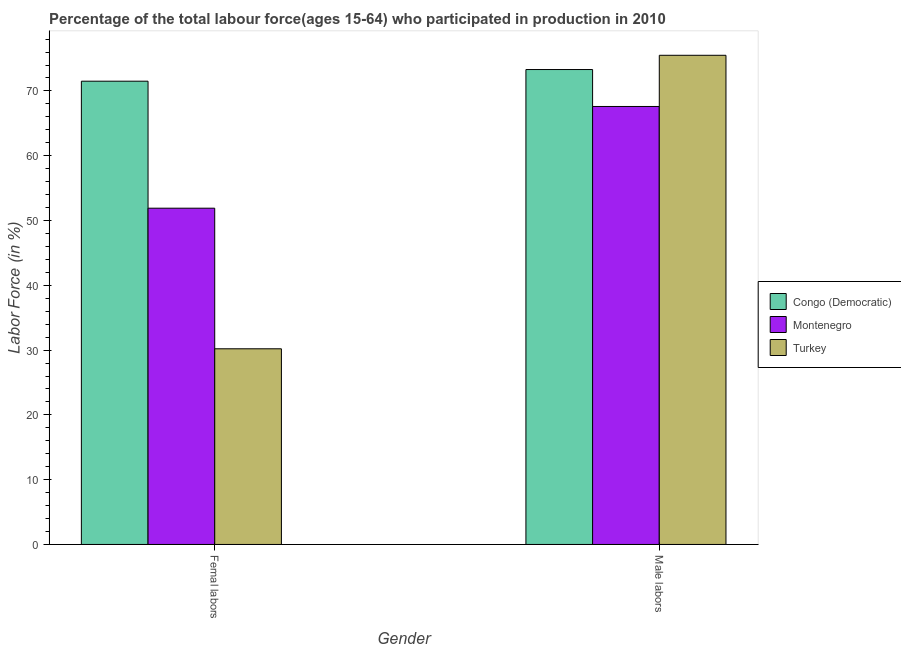How many different coloured bars are there?
Ensure brevity in your answer.  3. Are the number of bars on each tick of the X-axis equal?
Give a very brief answer. Yes. What is the label of the 2nd group of bars from the left?
Offer a very short reply. Male labors. What is the percentage of male labour force in Montenegro?
Keep it short and to the point. 67.6. Across all countries, what is the maximum percentage of female labor force?
Make the answer very short. 71.5. Across all countries, what is the minimum percentage of female labor force?
Your answer should be very brief. 30.2. In which country was the percentage of male labour force maximum?
Provide a succinct answer. Turkey. In which country was the percentage of male labour force minimum?
Provide a short and direct response. Montenegro. What is the total percentage of female labor force in the graph?
Provide a short and direct response. 153.6. What is the difference between the percentage of male labour force in Montenegro and that in Turkey?
Offer a very short reply. -7.9. What is the average percentage of female labor force per country?
Make the answer very short. 51.2. What is the difference between the percentage of female labor force and percentage of male labour force in Congo (Democratic)?
Make the answer very short. -1.8. In how many countries, is the percentage of female labor force greater than 52 %?
Offer a very short reply. 1. What is the ratio of the percentage of female labor force in Montenegro to that in Congo (Democratic)?
Offer a terse response. 0.73. What does the 3rd bar from the left in Femal labors represents?
Your response must be concise. Turkey. What does the 3rd bar from the right in Male labors represents?
Keep it short and to the point. Congo (Democratic). Are all the bars in the graph horizontal?
Provide a succinct answer. No. How are the legend labels stacked?
Offer a very short reply. Vertical. What is the title of the graph?
Your response must be concise. Percentage of the total labour force(ages 15-64) who participated in production in 2010. Does "Netherlands" appear as one of the legend labels in the graph?
Make the answer very short. No. What is the label or title of the X-axis?
Make the answer very short. Gender. What is the Labor Force (in %) of Congo (Democratic) in Femal labors?
Provide a succinct answer. 71.5. What is the Labor Force (in %) of Montenegro in Femal labors?
Your answer should be very brief. 51.9. What is the Labor Force (in %) of Turkey in Femal labors?
Provide a short and direct response. 30.2. What is the Labor Force (in %) of Congo (Democratic) in Male labors?
Offer a very short reply. 73.3. What is the Labor Force (in %) of Montenegro in Male labors?
Your response must be concise. 67.6. What is the Labor Force (in %) of Turkey in Male labors?
Provide a succinct answer. 75.5. Across all Gender, what is the maximum Labor Force (in %) of Congo (Democratic)?
Your response must be concise. 73.3. Across all Gender, what is the maximum Labor Force (in %) of Montenegro?
Offer a very short reply. 67.6. Across all Gender, what is the maximum Labor Force (in %) in Turkey?
Offer a terse response. 75.5. Across all Gender, what is the minimum Labor Force (in %) of Congo (Democratic)?
Offer a terse response. 71.5. Across all Gender, what is the minimum Labor Force (in %) in Montenegro?
Provide a succinct answer. 51.9. Across all Gender, what is the minimum Labor Force (in %) of Turkey?
Keep it short and to the point. 30.2. What is the total Labor Force (in %) of Congo (Democratic) in the graph?
Make the answer very short. 144.8. What is the total Labor Force (in %) of Montenegro in the graph?
Your response must be concise. 119.5. What is the total Labor Force (in %) of Turkey in the graph?
Ensure brevity in your answer.  105.7. What is the difference between the Labor Force (in %) in Congo (Democratic) in Femal labors and that in Male labors?
Provide a short and direct response. -1.8. What is the difference between the Labor Force (in %) in Montenegro in Femal labors and that in Male labors?
Your answer should be very brief. -15.7. What is the difference between the Labor Force (in %) in Turkey in Femal labors and that in Male labors?
Make the answer very short. -45.3. What is the difference between the Labor Force (in %) in Congo (Democratic) in Femal labors and the Labor Force (in %) in Montenegro in Male labors?
Ensure brevity in your answer.  3.9. What is the difference between the Labor Force (in %) in Montenegro in Femal labors and the Labor Force (in %) in Turkey in Male labors?
Provide a succinct answer. -23.6. What is the average Labor Force (in %) of Congo (Democratic) per Gender?
Offer a very short reply. 72.4. What is the average Labor Force (in %) in Montenegro per Gender?
Ensure brevity in your answer.  59.75. What is the average Labor Force (in %) of Turkey per Gender?
Your answer should be compact. 52.85. What is the difference between the Labor Force (in %) in Congo (Democratic) and Labor Force (in %) in Montenegro in Femal labors?
Your response must be concise. 19.6. What is the difference between the Labor Force (in %) in Congo (Democratic) and Labor Force (in %) in Turkey in Femal labors?
Provide a short and direct response. 41.3. What is the difference between the Labor Force (in %) in Montenegro and Labor Force (in %) in Turkey in Femal labors?
Make the answer very short. 21.7. What is the difference between the Labor Force (in %) of Congo (Democratic) and Labor Force (in %) of Montenegro in Male labors?
Keep it short and to the point. 5.7. What is the difference between the Labor Force (in %) in Congo (Democratic) and Labor Force (in %) in Turkey in Male labors?
Ensure brevity in your answer.  -2.2. What is the difference between the Labor Force (in %) in Montenegro and Labor Force (in %) in Turkey in Male labors?
Offer a terse response. -7.9. What is the ratio of the Labor Force (in %) in Congo (Democratic) in Femal labors to that in Male labors?
Your response must be concise. 0.98. What is the ratio of the Labor Force (in %) in Montenegro in Femal labors to that in Male labors?
Your answer should be compact. 0.77. What is the ratio of the Labor Force (in %) of Turkey in Femal labors to that in Male labors?
Make the answer very short. 0.4. What is the difference between the highest and the second highest Labor Force (in %) of Congo (Democratic)?
Your answer should be very brief. 1.8. What is the difference between the highest and the second highest Labor Force (in %) in Turkey?
Provide a succinct answer. 45.3. What is the difference between the highest and the lowest Labor Force (in %) of Congo (Democratic)?
Make the answer very short. 1.8. What is the difference between the highest and the lowest Labor Force (in %) of Turkey?
Offer a very short reply. 45.3. 